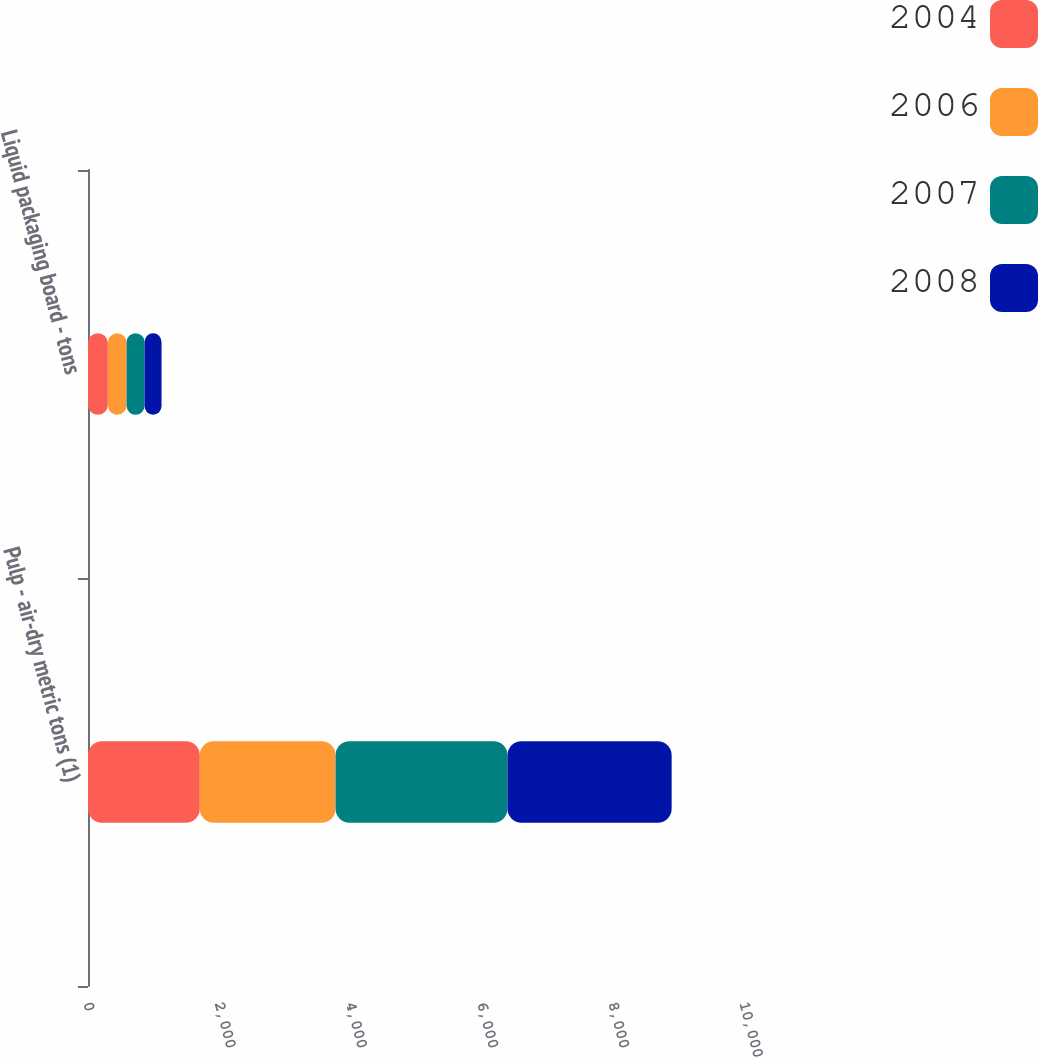Convert chart to OTSL. <chart><loc_0><loc_0><loc_500><loc_500><stacked_bar_chart><ecel><fcel>Pulp - air-dry metric tons (1)<fcel>Liquid packaging board - tons<nl><fcel>2004<fcel>1704<fcel>302<nl><fcel>2006<fcel>2070<fcel>286<nl><fcel>2007<fcel>2621<fcel>275<nl><fcel>2008<fcel>2502<fcel>258<nl></chart> 